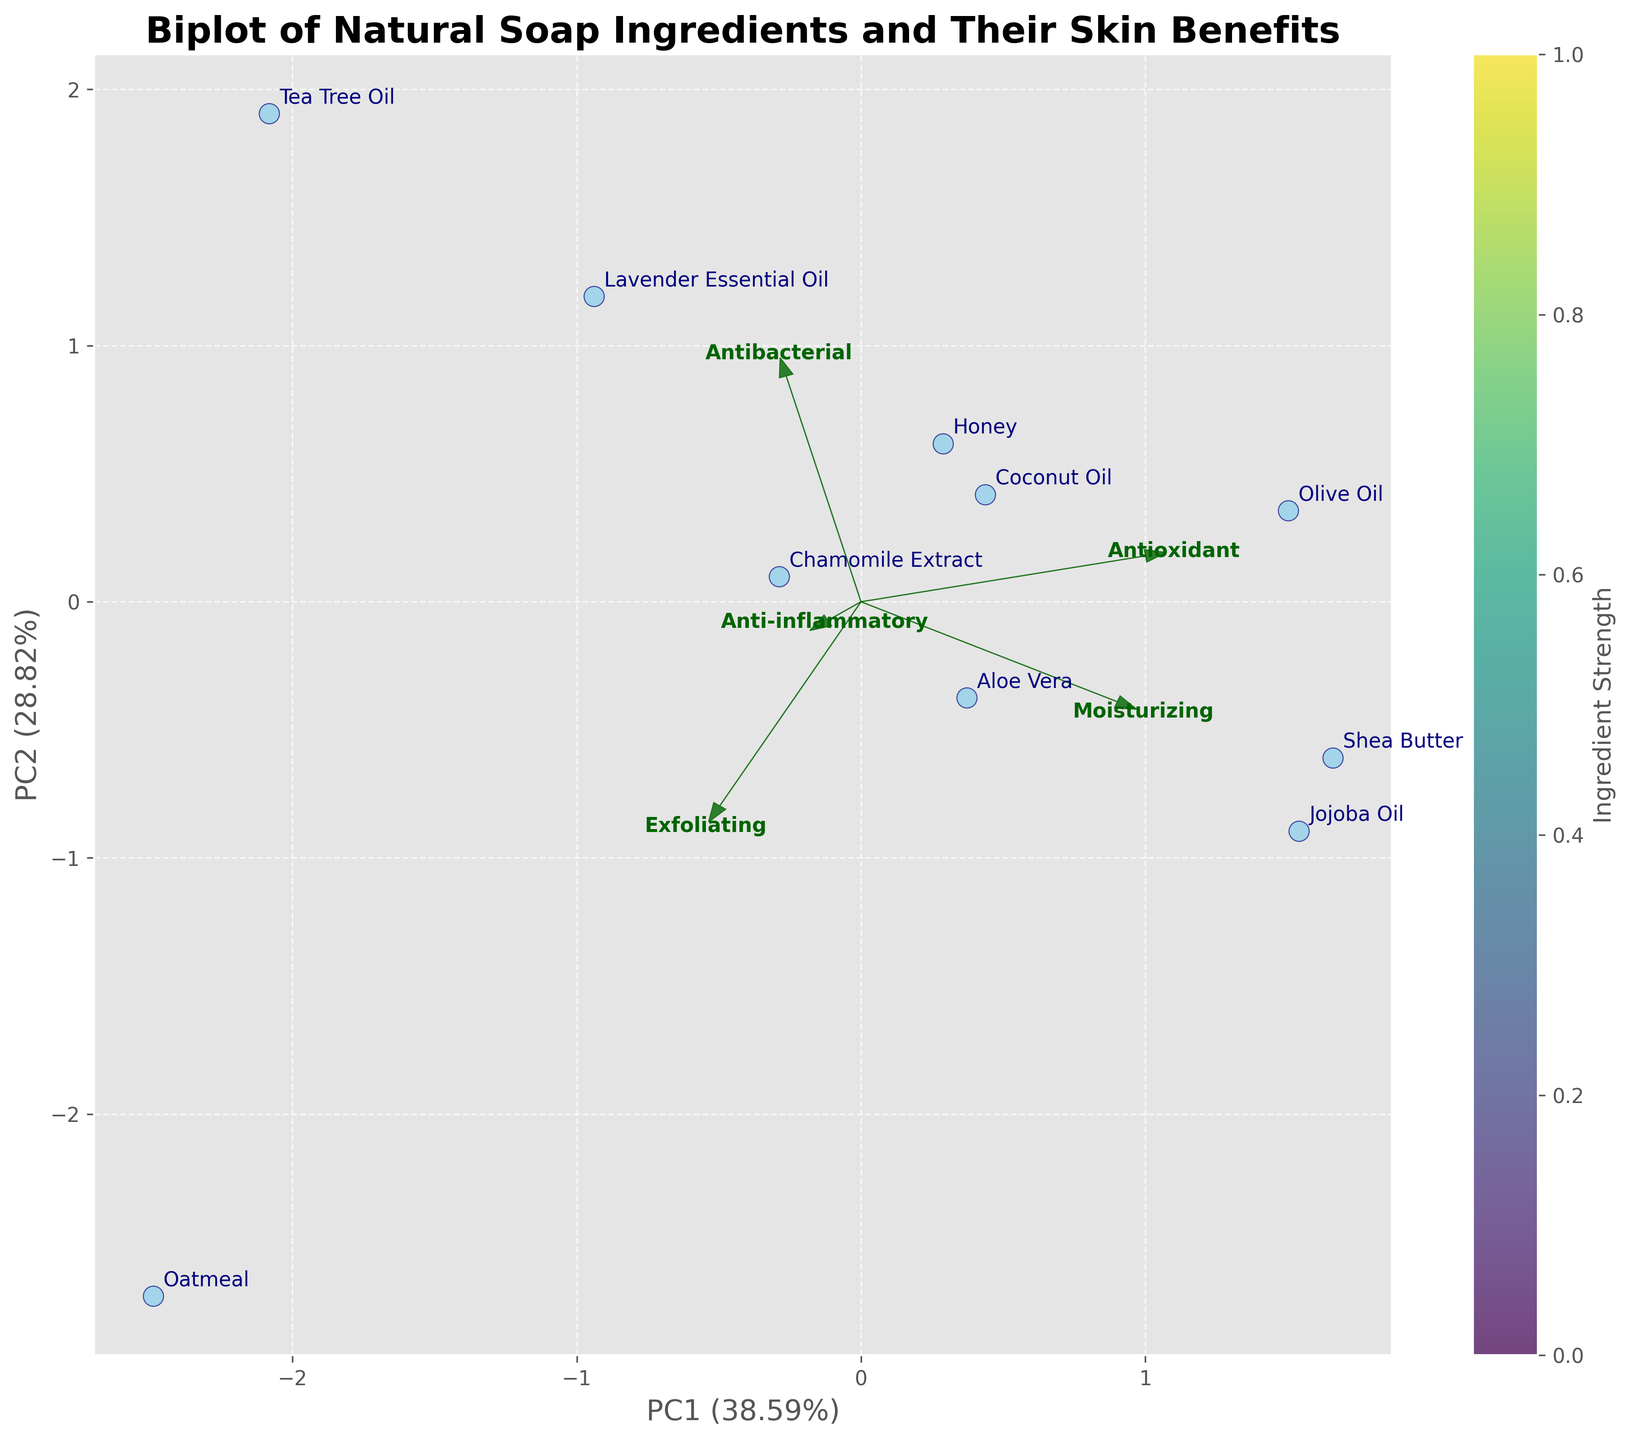What is the title of the biplot? The title is written at the top of the figure. It provides an overview of what the figure represents.
Answer: Biplot of Natural Soap Ingredients and Their Skin Benefits What ingredients show high moisturizing and high anti-inflammatory benefits? Ingredients are plotted on the biplot with their benefits. Look for the ingredients positioned to the right on the PC1 axis (moisturizing) and upward on the PC2 axis (anti-inflammatory).
Answer: Aloe Vera and Shea Butter Which skin benefit has the highest loading on the first principal component (PC1)? Loadings are represented by arrows. The length and direction of the arrow show the influence of each benefit on the principal components.
Answer: Moisturizing Which skin benefit category shows more contribution towards PC2: Anti-inflammatory or Antioxidant? By observing the arrows for Anti-inflammatory and Antioxidant, compare their length along the PC2 axis.
Answer: Anti-inflammatory Do Shea Butter and Jojoba Oil share similar skin benefits based on the plot? Look at the position of Shea Butter and Jojoba Oil. If they are close to each other on the plot, they share similar benefits.
Answer: Yes Which ingredient is closest to the origin of the plot? Find the data point that is nearest to the coordinates (0,0), indicating minimal deviation from the average.
Answer: Lavender Essential Oil Are ingredients with higher antibacterial properties grouped together? Check the plot to see if ingredients with higher antibacterial loadings (longer arrows in the Anti-inflammatory direction) are located near each other.
Answer: Yes Which two ingredients located furthest apart on the plot? Measure the distance between each pair of data points to find the two that have the greatest separation.
Answer: Tea Tree Oil and Aloe Vera How many ingredients show significant antioxidant benefits? Look for the antioxidant arrow and count data points positioned in line with or beyond this arrow.
Answer: Three ingredients (Olive Oil, Honey, Shea Butter) Is moisturizing or exfoliating more associated with PC1? Compare the direction and length of the arrows for moisturizing and exfoliating to see which one aligns more closely with the PC1 axis.
Answer: Moisturizing 